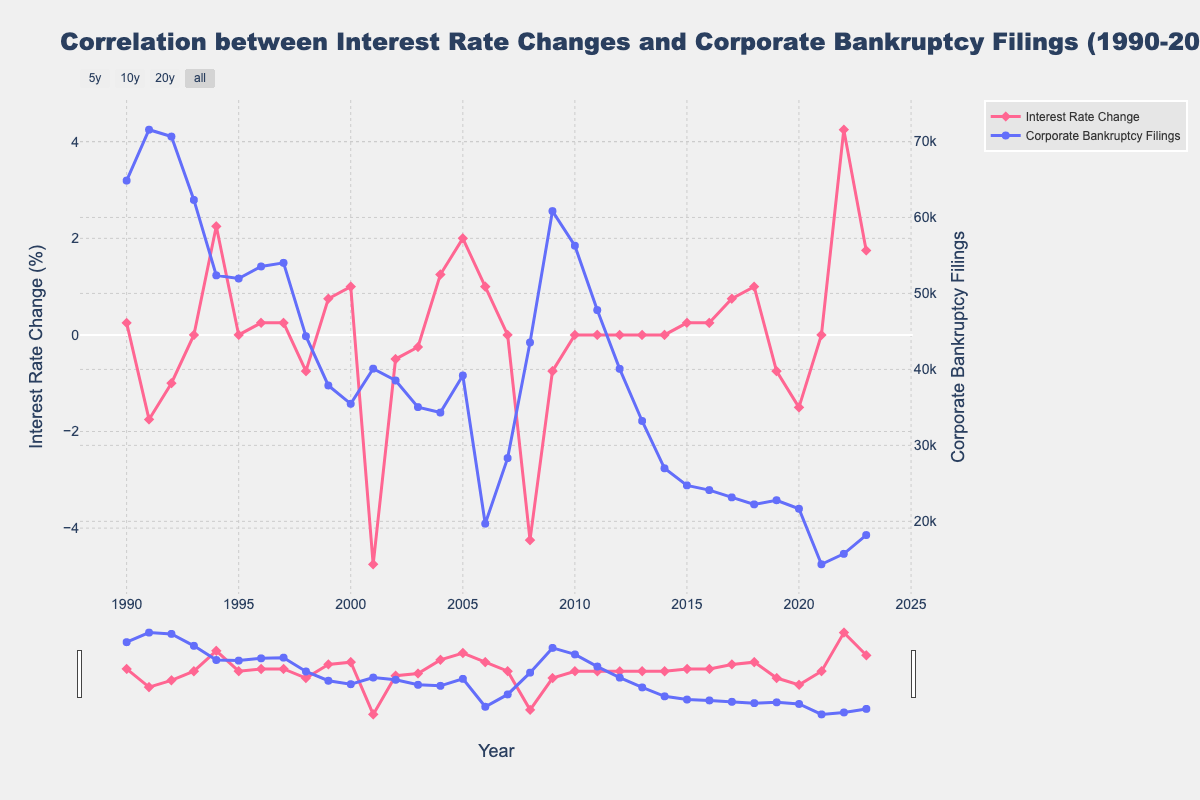What year had the highest corporate bankruptcy filings? To determine the year with the highest corporate bankruptcy filings, one should visually scan the line representing these filings and look for the peak point. The highest point on the blue line corresponds to the year 1991 with 71,549 filings.
Answer: 1991 How does the change in interest rates in 2008 compare with corporate bankruptcy filings in the same year? For this comparison, observe the value of interest rate change in 2008 and compare it with the corporate bankruptcy filings for that year. The interest rate change in 2008 was -4.25% while the corporate bankruptcy filings were 43,546.
Answer: -4.25% and 43,546 Which year had the most significant drop in corporate bankruptcy filings from the previous year, and what was the magnitude of this drop? Examine the plot to identify the steepest decline in the blue line, then calculate the difference between the points at the start and end of this decline. The most significant drop occurred between 2006 and 2007, where filings dropped from 19,695 to 28,322, a difference of 28,322 - 19,695 = 8,627.
Answer: 2007, 8,627 Was there any year where both the interest rate change and corporate bankruptcy filings were constant compared to the previous year? Look for years where the line representing the interest rate change stays flat (0%) and the corporate bankruptcy filings line also shows no change compared to the previous year. Both lines were constant in 2010 and 2011.
Answer: Yes, 2010-2011 What is the overall trend of corporate bankruptcy filings from 1990 to 2023? Assess the trajectory of the blue line throughout the entire time period from 1990 to 2023, noting the general direction or patterns. The overall trend shows a general decrease in corporate bankruptcy filings from 1990 to 2023 with some fluctuations.
Answer: Decreasing trend Which year showed the greatest positive interest rate change, and what was its impact on corporate bankruptcy filings? Identify the year where the pink line representing interest rate changes peaks positively, and examine the corresponding value for corporate bankruptcy filings in that year. The greatest positive interest rate change was in 2022 with 4.25%, and the corporate bankruptcy filings were 15,724.
Answer: 2022, 15,724 How did corporate bankruptcy filings change following the significant negative interest rate change in 2001? Observe the value for interest rate change in 2001 and the change in corporate bankruptcy filings in the subsequent year, 2002. In 2001, the interest rate change was -4.75%, and the corporate bankruptcy filings fell from 40,099 in 2001 to 38,540 in 2002.
Answer: Decreased What is the correlation between interest rate changes and corporate bankruptcy filings in 2023? Examine the plot for the interest rate change and corporate bankruptcy filings in 2023. The interest rate change was 1.75%, and corporate bankruptcy filings were 18,195.
Answer: 1.75% and 18,195 